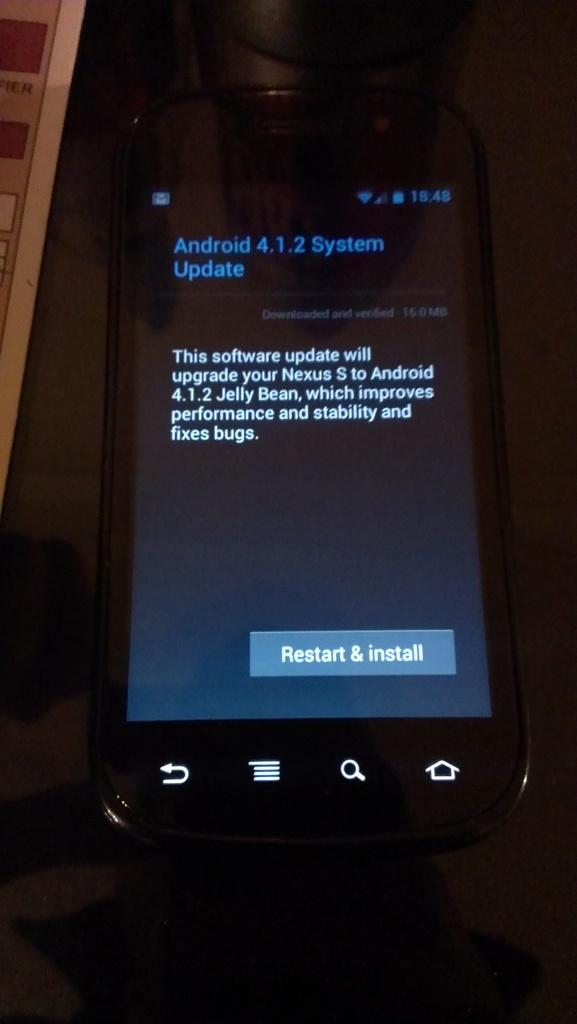What sort of phone is that?
Keep it short and to the point. Android. What is in the text box at the bottom of the screen?
Make the answer very short. Restart & install. 